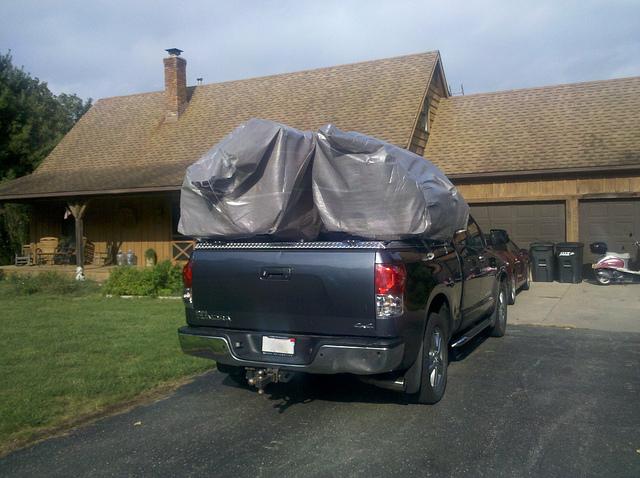Are those bags stuffed?
Quick response, please. Yes. What is in the back of the truck?
Concise answer only. Tarp. Is this family moving out?
Short answer required. Yes. 